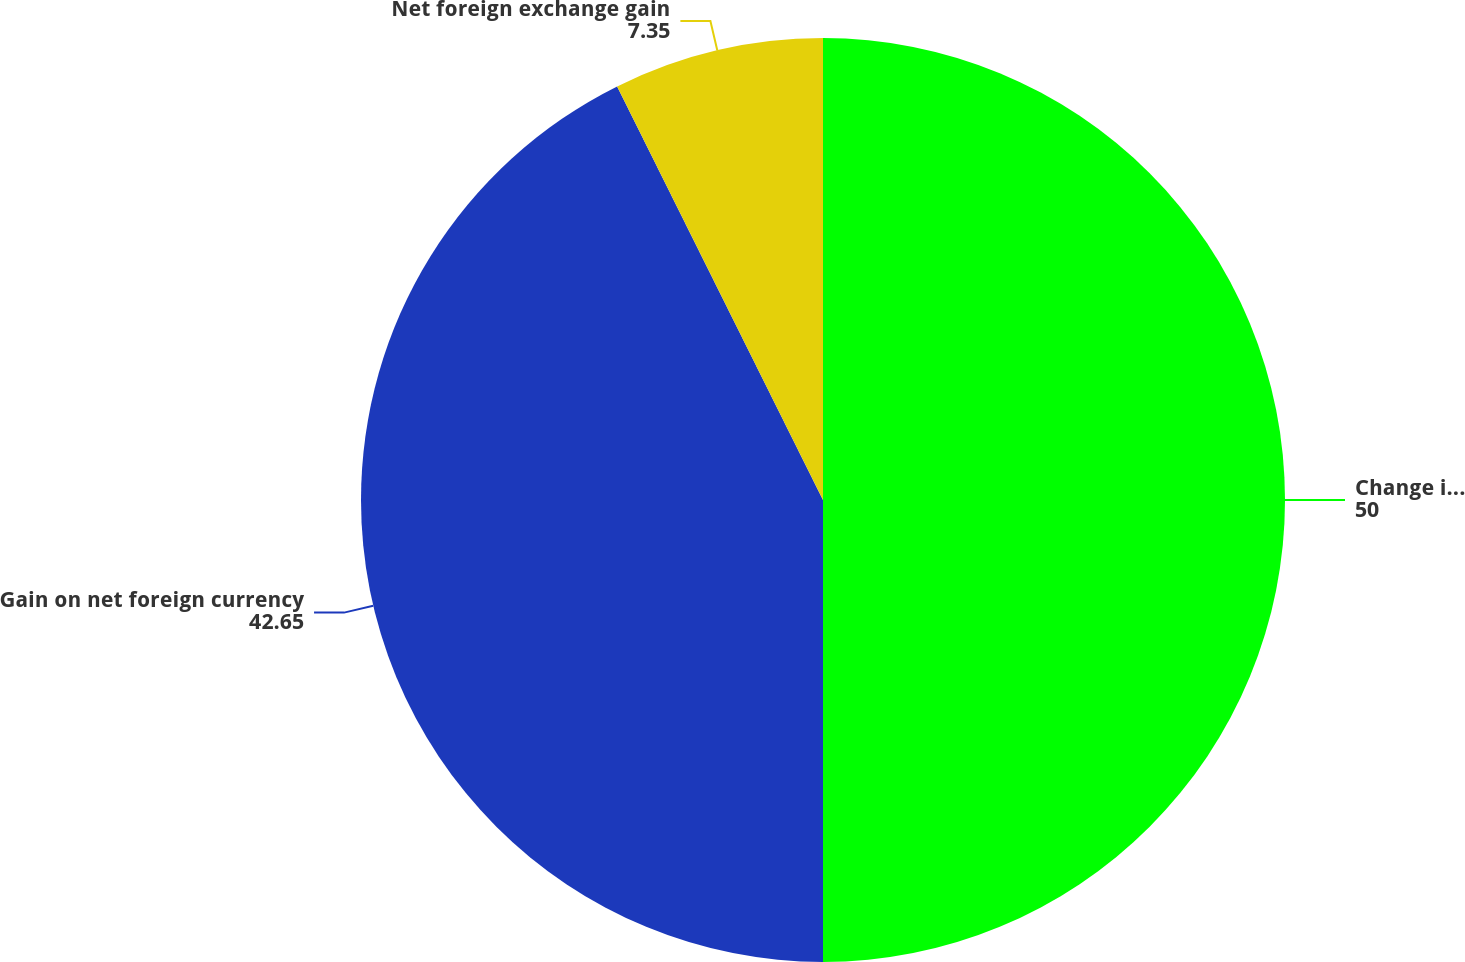<chart> <loc_0><loc_0><loc_500><loc_500><pie_chart><fcel>Change in gains (losses) from<fcel>Gain on net foreign currency<fcel>Net foreign exchange gain<nl><fcel>50.0%<fcel>42.65%<fcel>7.35%<nl></chart> 